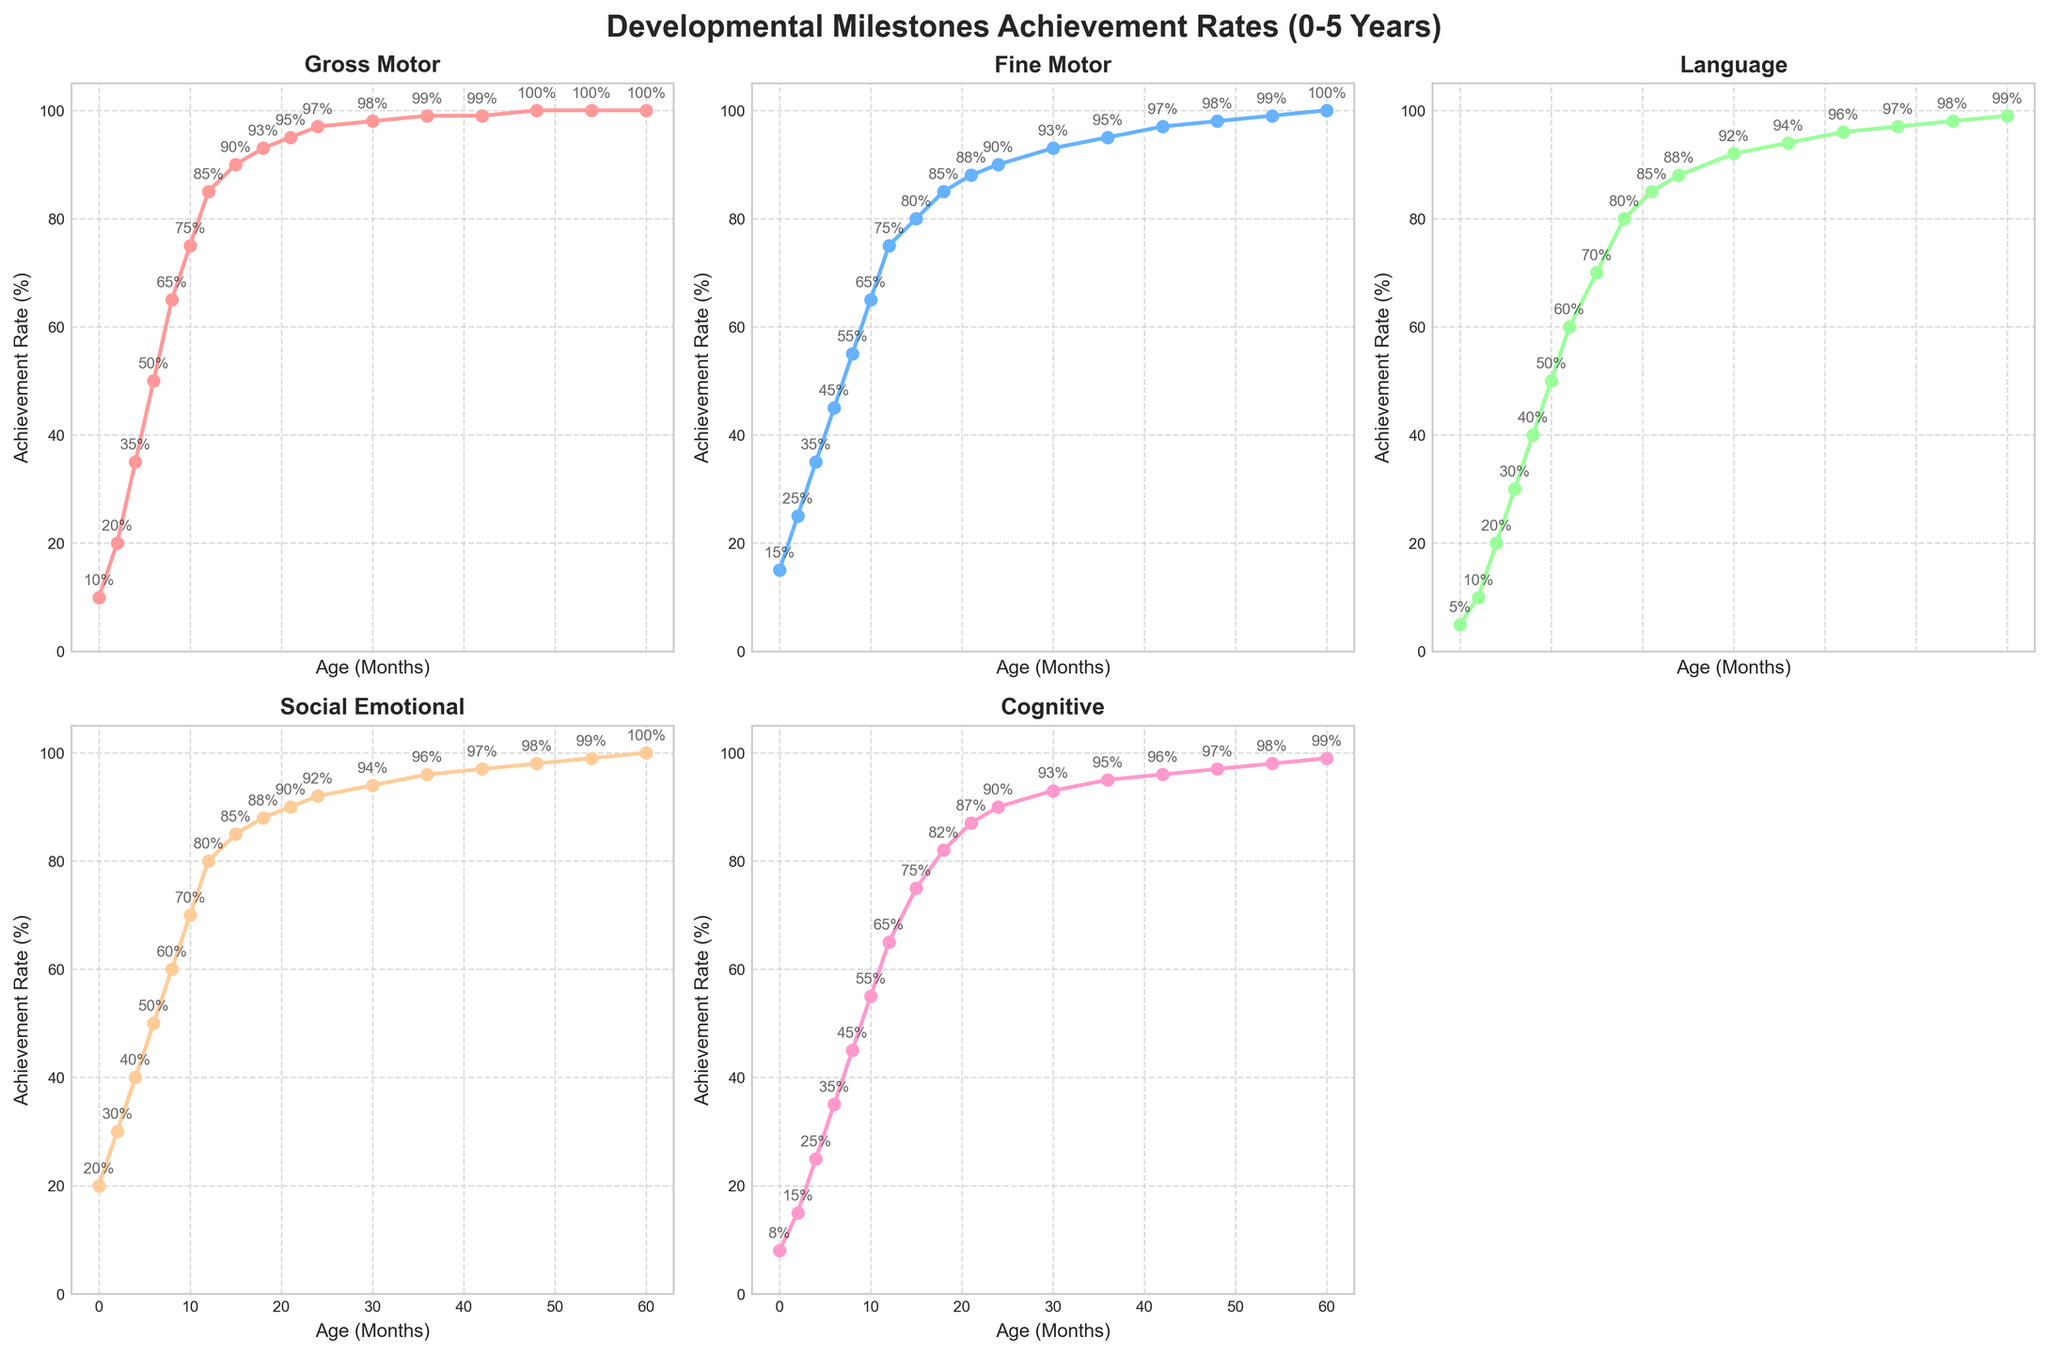What is the growth trend for the Gross Motor category from 0 to 60 months? The Gross Motor achievement rate starts at 10% and steadily increases to 100% by 60 months. This indicates a consistent upward trend in achievement rates.
Answer: Consistent upward trend At which age is the fastest increase in Language development observed? From the graph, the biggest rise in Language occurs between 6 and 10 months, where the rate jumps from 30% to 50%, a 20% increase.
Answer: 6 to 10 months Which developmental category hits 100% achievement rate first, and at what age? The Gross Motor category reaches 100% at 48 months, which is earlier than any other category.
Answer: Gross Motor at 48 months How do the achievement rates of Fine Motor and Language compare at 12 months? At 12 months, the Fine Motor rate is 75% and the Language rate is 60%.
Answer: Fine Motor > Language What is the average achievement rate of Social Emotional and Cognitive categories at 24 months? Social Emotional is 92%, and Cognitive is 90%. Average: (92 + 90) / 2 = 91%.
Answer: 91% What range of achievement rates do all six categories cover by the age of 18 months? At 18 months, the rates for each category are: Gross Motor - 93%, Fine Motor - 85%, Language - 80%, Social Emotional - 88%, and Cognitive - 82%. All categories fall within the range 80%-93%.
Answer: 80%-93% Which category shows the closest achievement rates from age 24 to 60 months? Both Gross Motor and Fine Motor categories show minimal increases and approach 100% over this period, indicating closely matched rates.
Answer: Gross Motor and Fine Motor What is the total increase in Social Emotional achievement rate from age 0 to age 12 months? Social Emotional starts at 20% at 0 months and reaches 80% at 12 months. Increase = 80% - 20% = 60%.
Answer: 60% How does Cognitive development at 36 months compare to Language development at the same age? At 36 months, Cognitive development is at 95%, while Language development is at 94%.
Answer: Cognitive > Language Which category has the flattest growth curve, indicating a more gradual increase in achievements? The Social Emotional category appears to have the most gradual increase, indicating the flattest growth curve.
Answer: Social Emotional 